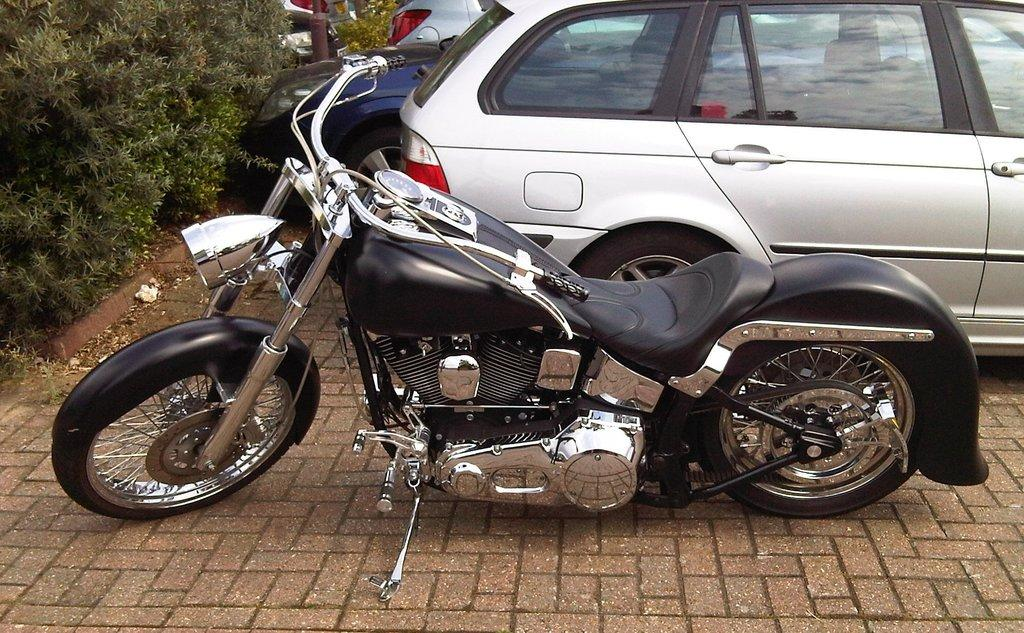What can be seen on the pavement in the foreground of the image? There is a bike on the pavement in the foreground of the image. What type of vegetation is on the left side of the image? There are plants on the left side of the image. What can be seen in the background of the image? There are cars and a pole in the background of the image. What type of suit can be seen hanging on the pole in the background? There is no suit present in the image; it only features a bike, plants, cars, and a pole. 